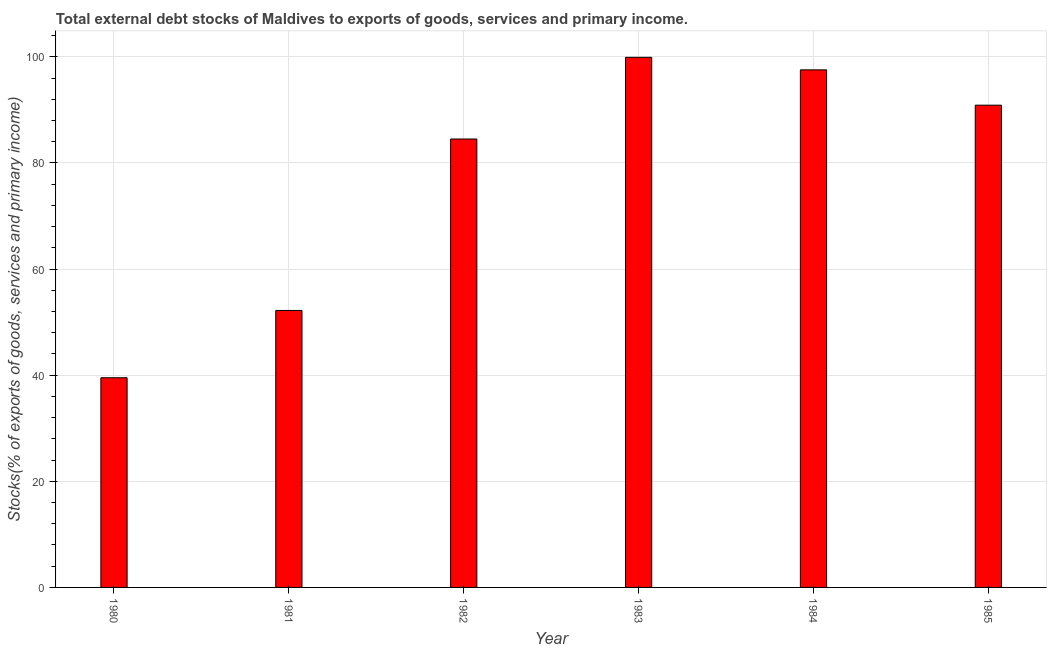What is the title of the graph?
Offer a very short reply. Total external debt stocks of Maldives to exports of goods, services and primary income. What is the label or title of the Y-axis?
Offer a terse response. Stocks(% of exports of goods, services and primary income). What is the external debt stocks in 1983?
Give a very brief answer. 99.9. Across all years, what is the maximum external debt stocks?
Ensure brevity in your answer.  99.9. Across all years, what is the minimum external debt stocks?
Your response must be concise. 39.51. What is the sum of the external debt stocks?
Keep it short and to the point. 464.53. What is the difference between the external debt stocks in 1982 and 1983?
Keep it short and to the point. -15.39. What is the average external debt stocks per year?
Offer a very short reply. 77.42. What is the median external debt stocks?
Your answer should be very brief. 87.69. In how many years, is the external debt stocks greater than 32 %?
Your answer should be compact. 6. Do a majority of the years between 1984 and 1982 (inclusive) have external debt stocks greater than 76 %?
Your response must be concise. Yes. What is the ratio of the external debt stocks in 1982 to that in 1983?
Make the answer very short. 0.85. Is the external debt stocks in 1982 less than that in 1984?
Keep it short and to the point. Yes. What is the difference between the highest and the second highest external debt stocks?
Provide a short and direct response. 2.36. Is the sum of the external debt stocks in 1980 and 1983 greater than the maximum external debt stocks across all years?
Keep it short and to the point. Yes. What is the difference between the highest and the lowest external debt stocks?
Make the answer very short. 60.39. In how many years, is the external debt stocks greater than the average external debt stocks taken over all years?
Your answer should be very brief. 4. Are the values on the major ticks of Y-axis written in scientific E-notation?
Offer a terse response. No. What is the Stocks(% of exports of goods, services and primary income) in 1980?
Offer a terse response. 39.51. What is the Stocks(% of exports of goods, services and primary income) of 1981?
Ensure brevity in your answer.  52.2. What is the Stocks(% of exports of goods, services and primary income) in 1982?
Make the answer very short. 84.51. What is the Stocks(% of exports of goods, services and primary income) in 1983?
Your response must be concise. 99.9. What is the Stocks(% of exports of goods, services and primary income) in 1984?
Ensure brevity in your answer.  97.54. What is the Stocks(% of exports of goods, services and primary income) of 1985?
Offer a terse response. 90.88. What is the difference between the Stocks(% of exports of goods, services and primary income) in 1980 and 1981?
Keep it short and to the point. -12.68. What is the difference between the Stocks(% of exports of goods, services and primary income) in 1980 and 1982?
Ensure brevity in your answer.  -44.99. What is the difference between the Stocks(% of exports of goods, services and primary income) in 1980 and 1983?
Offer a terse response. -60.39. What is the difference between the Stocks(% of exports of goods, services and primary income) in 1980 and 1984?
Ensure brevity in your answer.  -58.02. What is the difference between the Stocks(% of exports of goods, services and primary income) in 1980 and 1985?
Make the answer very short. -51.37. What is the difference between the Stocks(% of exports of goods, services and primary income) in 1981 and 1982?
Provide a short and direct response. -32.31. What is the difference between the Stocks(% of exports of goods, services and primary income) in 1981 and 1983?
Keep it short and to the point. -47.7. What is the difference between the Stocks(% of exports of goods, services and primary income) in 1981 and 1984?
Make the answer very short. -45.34. What is the difference between the Stocks(% of exports of goods, services and primary income) in 1981 and 1985?
Your answer should be compact. -38.69. What is the difference between the Stocks(% of exports of goods, services and primary income) in 1982 and 1983?
Your response must be concise. -15.39. What is the difference between the Stocks(% of exports of goods, services and primary income) in 1982 and 1984?
Your answer should be very brief. -13.03. What is the difference between the Stocks(% of exports of goods, services and primary income) in 1982 and 1985?
Offer a very short reply. -6.38. What is the difference between the Stocks(% of exports of goods, services and primary income) in 1983 and 1984?
Give a very brief answer. 2.36. What is the difference between the Stocks(% of exports of goods, services and primary income) in 1983 and 1985?
Offer a very short reply. 9.02. What is the difference between the Stocks(% of exports of goods, services and primary income) in 1984 and 1985?
Ensure brevity in your answer.  6.65. What is the ratio of the Stocks(% of exports of goods, services and primary income) in 1980 to that in 1981?
Your answer should be very brief. 0.76. What is the ratio of the Stocks(% of exports of goods, services and primary income) in 1980 to that in 1982?
Your response must be concise. 0.47. What is the ratio of the Stocks(% of exports of goods, services and primary income) in 1980 to that in 1983?
Provide a succinct answer. 0.4. What is the ratio of the Stocks(% of exports of goods, services and primary income) in 1980 to that in 1984?
Your answer should be compact. 0.41. What is the ratio of the Stocks(% of exports of goods, services and primary income) in 1980 to that in 1985?
Ensure brevity in your answer.  0.43. What is the ratio of the Stocks(% of exports of goods, services and primary income) in 1981 to that in 1982?
Your answer should be compact. 0.62. What is the ratio of the Stocks(% of exports of goods, services and primary income) in 1981 to that in 1983?
Your answer should be very brief. 0.52. What is the ratio of the Stocks(% of exports of goods, services and primary income) in 1981 to that in 1984?
Provide a short and direct response. 0.54. What is the ratio of the Stocks(% of exports of goods, services and primary income) in 1981 to that in 1985?
Keep it short and to the point. 0.57. What is the ratio of the Stocks(% of exports of goods, services and primary income) in 1982 to that in 1983?
Provide a short and direct response. 0.85. What is the ratio of the Stocks(% of exports of goods, services and primary income) in 1982 to that in 1984?
Your response must be concise. 0.87. What is the ratio of the Stocks(% of exports of goods, services and primary income) in 1982 to that in 1985?
Your response must be concise. 0.93. What is the ratio of the Stocks(% of exports of goods, services and primary income) in 1983 to that in 1984?
Your answer should be very brief. 1.02. What is the ratio of the Stocks(% of exports of goods, services and primary income) in 1983 to that in 1985?
Give a very brief answer. 1.1. What is the ratio of the Stocks(% of exports of goods, services and primary income) in 1984 to that in 1985?
Your answer should be very brief. 1.07. 